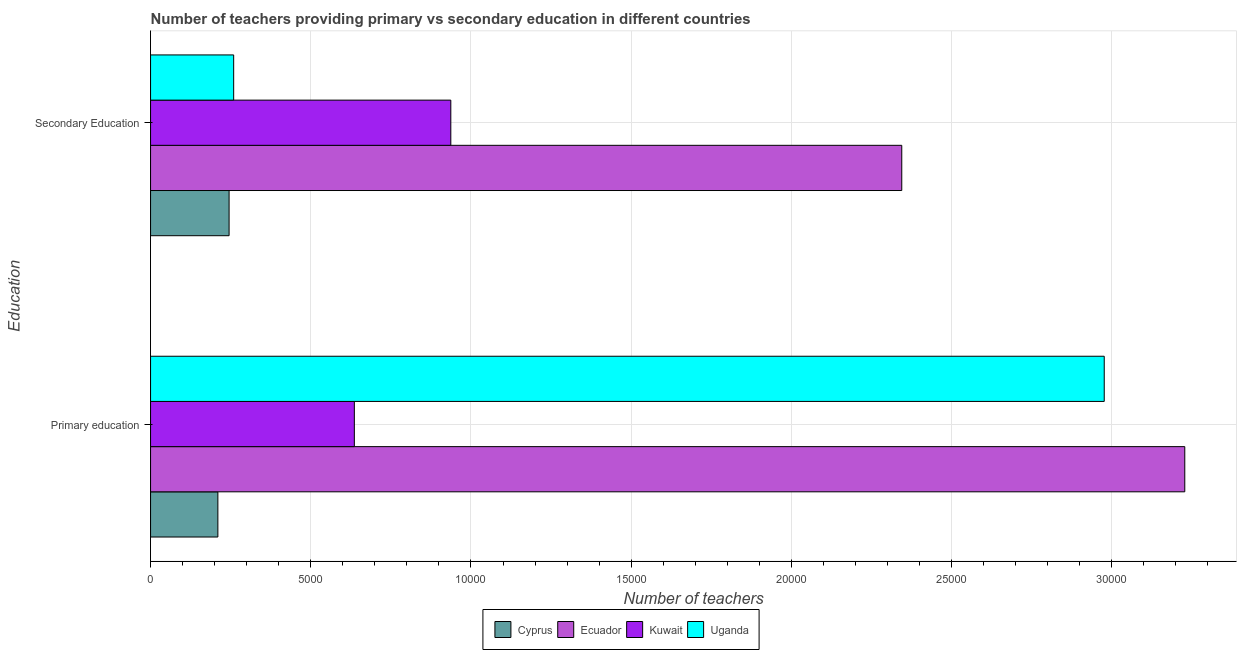How many different coloured bars are there?
Offer a terse response. 4. Are the number of bars per tick equal to the number of legend labels?
Offer a very short reply. Yes. Are the number of bars on each tick of the Y-axis equal?
Offer a very short reply. Yes. How many bars are there on the 1st tick from the top?
Offer a very short reply. 4. How many bars are there on the 2nd tick from the bottom?
Your answer should be compact. 4. What is the label of the 1st group of bars from the top?
Your response must be concise. Secondary Education. What is the number of primary teachers in Ecuador?
Provide a short and direct response. 3.23e+04. Across all countries, what is the maximum number of primary teachers?
Your answer should be very brief. 3.23e+04. Across all countries, what is the minimum number of primary teachers?
Your response must be concise. 2101. In which country was the number of primary teachers maximum?
Your answer should be very brief. Ecuador. In which country was the number of secondary teachers minimum?
Make the answer very short. Cyprus. What is the total number of primary teachers in the graph?
Your response must be concise. 7.05e+04. What is the difference between the number of secondary teachers in Uganda and that in Ecuador?
Provide a short and direct response. -2.09e+04. What is the difference between the number of primary teachers in Ecuador and the number of secondary teachers in Uganda?
Ensure brevity in your answer.  2.97e+04. What is the average number of secondary teachers per country?
Ensure brevity in your answer.  9465.5. What is the difference between the number of secondary teachers and number of primary teachers in Uganda?
Offer a terse response. -2.72e+04. What is the ratio of the number of secondary teachers in Kuwait to that in Ecuador?
Provide a short and direct response. 0.4. Is the number of primary teachers in Ecuador less than that in Uganda?
Give a very brief answer. No. What does the 3rd bar from the top in Primary education represents?
Your response must be concise. Ecuador. What does the 2nd bar from the bottom in Secondary Education represents?
Provide a short and direct response. Ecuador. How many bars are there?
Provide a succinct answer. 8. How many countries are there in the graph?
Ensure brevity in your answer.  4. Are the values on the major ticks of X-axis written in scientific E-notation?
Keep it short and to the point. No. Does the graph contain any zero values?
Your response must be concise. No. Does the graph contain grids?
Provide a succinct answer. Yes. How are the legend labels stacked?
Provide a succinct answer. Horizontal. What is the title of the graph?
Your answer should be very brief. Number of teachers providing primary vs secondary education in different countries. Does "Nicaragua" appear as one of the legend labels in the graph?
Your response must be concise. No. What is the label or title of the X-axis?
Make the answer very short. Number of teachers. What is the label or title of the Y-axis?
Offer a very short reply. Education. What is the Number of teachers in Cyprus in Primary education?
Provide a short and direct response. 2101. What is the Number of teachers in Ecuador in Primary education?
Make the answer very short. 3.23e+04. What is the Number of teachers of Kuwait in Primary education?
Offer a very short reply. 6360. What is the Number of teachers in Uganda in Primary education?
Provide a short and direct response. 2.98e+04. What is the Number of teachers of Cyprus in Secondary Education?
Your answer should be very brief. 2451. What is the Number of teachers of Ecuador in Secondary Education?
Ensure brevity in your answer.  2.34e+04. What is the Number of teachers of Kuwait in Secondary Education?
Give a very brief answer. 9371. What is the Number of teachers of Uganda in Secondary Education?
Your answer should be very brief. 2594. Across all Education, what is the maximum Number of teachers of Cyprus?
Provide a short and direct response. 2451. Across all Education, what is the maximum Number of teachers in Ecuador?
Offer a very short reply. 3.23e+04. Across all Education, what is the maximum Number of teachers of Kuwait?
Make the answer very short. 9371. Across all Education, what is the maximum Number of teachers of Uganda?
Make the answer very short. 2.98e+04. Across all Education, what is the minimum Number of teachers in Cyprus?
Provide a succinct answer. 2101. Across all Education, what is the minimum Number of teachers in Ecuador?
Give a very brief answer. 2.34e+04. Across all Education, what is the minimum Number of teachers of Kuwait?
Provide a short and direct response. 6360. Across all Education, what is the minimum Number of teachers in Uganda?
Ensure brevity in your answer.  2594. What is the total Number of teachers of Cyprus in the graph?
Give a very brief answer. 4552. What is the total Number of teachers in Ecuador in the graph?
Give a very brief answer. 5.57e+04. What is the total Number of teachers of Kuwait in the graph?
Your answer should be compact. 1.57e+04. What is the total Number of teachers in Uganda in the graph?
Keep it short and to the point. 3.24e+04. What is the difference between the Number of teachers of Cyprus in Primary education and that in Secondary Education?
Provide a short and direct response. -350. What is the difference between the Number of teachers of Ecuador in Primary education and that in Secondary Education?
Ensure brevity in your answer.  8833. What is the difference between the Number of teachers of Kuwait in Primary education and that in Secondary Education?
Offer a very short reply. -3011. What is the difference between the Number of teachers of Uganda in Primary education and that in Secondary Education?
Keep it short and to the point. 2.72e+04. What is the difference between the Number of teachers of Cyprus in Primary education and the Number of teachers of Ecuador in Secondary Education?
Your answer should be compact. -2.13e+04. What is the difference between the Number of teachers of Cyprus in Primary education and the Number of teachers of Kuwait in Secondary Education?
Make the answer very short. -7270. What is the difference between the Number of teachers of Cyprus in Primary education and the Number of teachers of Uganda in Secondary Education?
Provide a short and direct response. -493. What is the difference between the Number of teachers of Ecuador in Primary education and the Number of teachers of Kuwait in Secondary Education?
Provide a short and direct response. 2.29e+04. What is the difference between the Number of teachers of Ecuador in Primary education and the Number of teachers of Uganda in Secondary Education?
Your answer should be compact. 2.97e+04. What is the difference between the Number of teachers of Kuwait in Primary education and the Number of teachers of Uganda in Secondary Education?
Your answer should be very brief. 3766. What is the average Number of teachers in Cyprus per Education?
Provide a succinct answer. 2276. What is the average Number of teachers of Ecuador per Education?
Your answer should be compact. 2.79e+04. What is the average Number of teachers of Kuwait per Education?
Your answer should be compact. 7865.5. What is the average Number of teachers of Uganda per Education?
Offer a terse response. 1.62e+04. What is the difference between the Number of teachers in Cyprus and Number of teachers in Ecuador in Primary education?
Provide a short and direct response. -3.02e+04. What is the difference between the Number of teachers in Cyprus and Number of teachers in Kuwait in Primary education?
Keep it short and to the point. -4259. What is the difference between the Number of teachers in Cyprus and Number of teachers in Uganda in Primary education?
Keep it short and to the point. -2.77e+04. What is the difference between the Number of teachers in Ecuador and Number of teachers in Kuwait in Primary education?
Offer a very short reply. 2.59e+04. What is the difference between the Number of teachers in Ecuador and Number of teachers in Uganda in Primary education?
Ensure brevity in your answer.  2514. What is the difference between the Number of teachers in Kuwait and Number of teachers in Uganda in Primary education?
Your answer should be very brief. -2.34e+04. What is the difference between the Number of teachers of Cyprus and Number of teachers of Ecuador in Secondary Education?
Provide a succinct answer. -2.10e+04. What is the difference between the Number of teachers in Cyprus and Number of teachers in Kuwait in Secondary Education?
Ensure brevity in your answer.  -6920. What is the difference between the Number of teachers in Cyprus and Number of teachers in Uganda in Secondary Education?
Provide a succinct answer. -143. What is the difference between the Number of teachers of Ecuador and Number of teachers of Kuwait in Secondary Education?
Make the answer very short. 1.41e+04. What is the difference between the Number of teachers of Ecuador and Number of teachers of Uganda in Secondary Education?
Make the answer very short. 2.09e+04. What is the difference between the Number of teachers of Kuwait and Number of teachers of Uganda in Secondary Education?
Offer a very short reply. 6777. What is the ratio of the Number of teachers in Cyprus in Primary education to that in Secondary Education?
Provide a short and direct response. 0.86. What is the ratio of the Number of teachers of Ecuador in Primary education to that in Secondary Education?
Your response must be concise. 1.38. What is the ratio of the Number of teachers in Kuwait in Primary education to that in Secondary Education?
Ensure brevity in your answer.  0.68. What is the ratio of the Number of teachers in Uganda in Primary education to that in Secondary Education?
Your answer should be compact. 11.47. What is the difference between the highest and the second highest Number of teachers in Cyprus?
Keep it short and to the point. 350. What is the difference between the highest and the second highest Number of teachers of Ecuador?
Offer a terse response. 8833. What is the difference between the highest and the second highest Number of teachers in Kuwait?
Your answer should be compact. 3011. What is the difference between the highest and the second highest Number of teachers in Uganda?
Provide a succinct answer. 2.72e+04. What is the difference between the highest and the lowest Number of teachers of Cyprus?
Provide a short and direct response. 350. What is the difference between the highest and the lowest Number of teachers in Ecuador?
Keep it short and to the point. 8833. What is the difference between the highest and the lowest Number of teachers in Kuwait?
Make the answer very short. 3011. What is the difference between the highest and the lowest Number of teachers in Uganda?
Provide a succinct answer. 2.72e+04. 